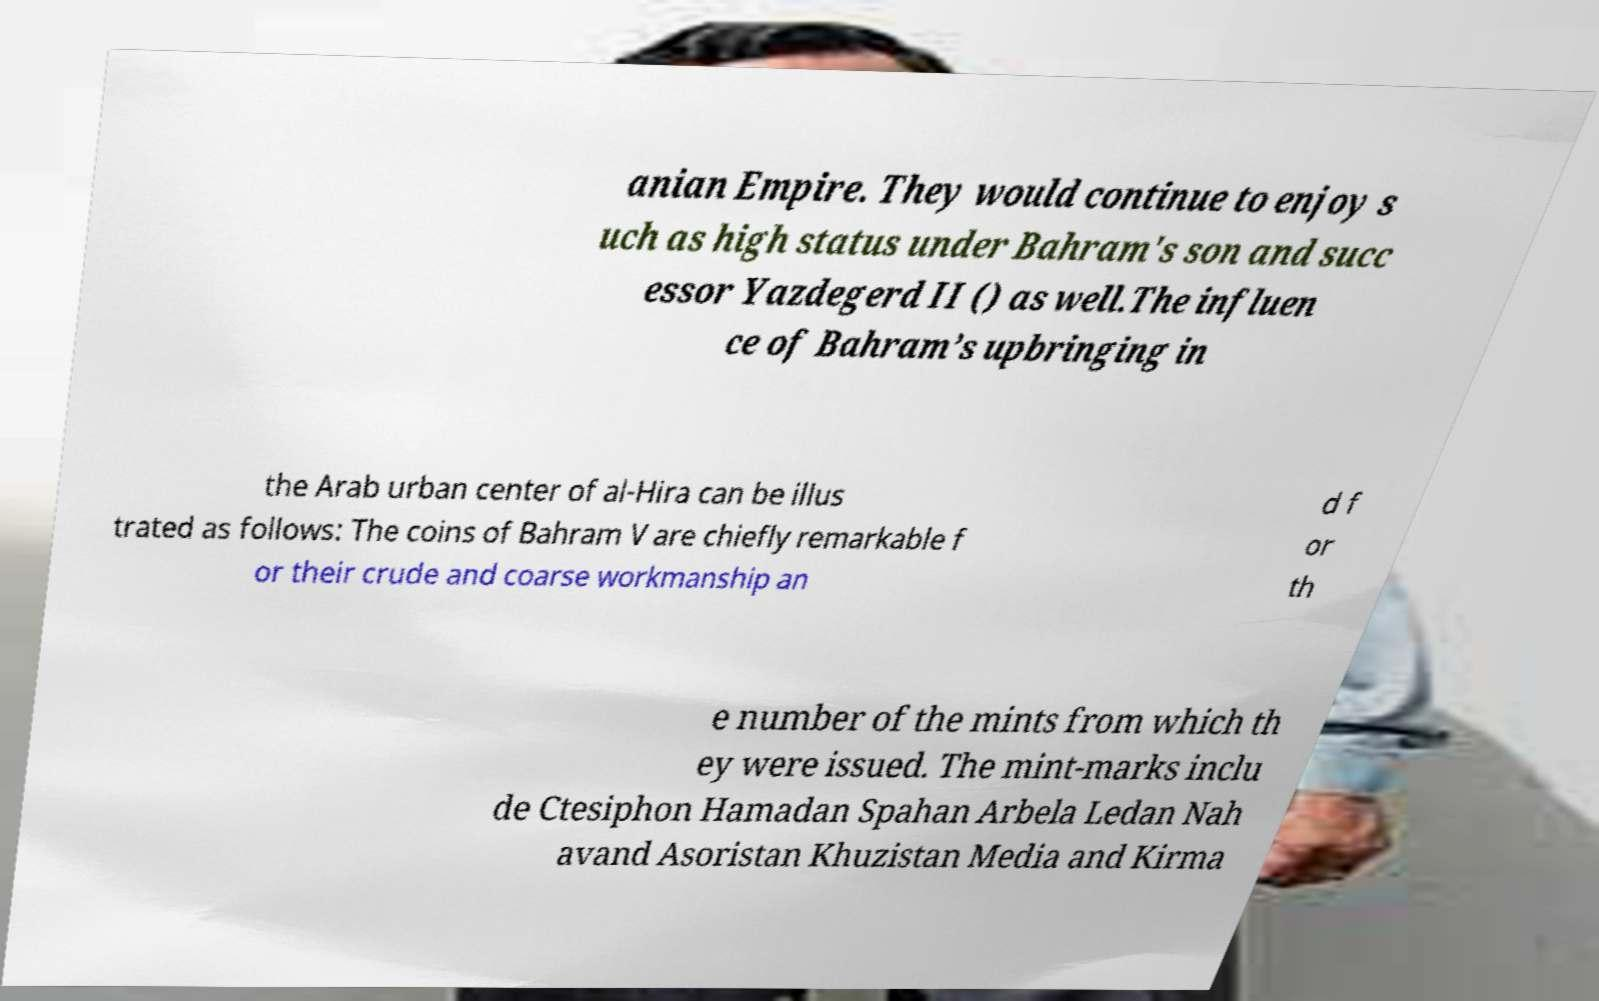Please read and relay the text visible in this image. What does it say? anian Empire. They would continue to enjoy s uch as high status under Bahram's son and succ essor Yazdegerd II () as well.The influen ce of Bahram’s upbringing in the Arab urban center of al-Hira can be illus trated as follows: The coins of Bahram V are chiefly remarkable f or their crude and coarse workmanship an d f or th e number of the mints from which th ey were issued. The mint-marks inclu de Ctesiphon Hamadan Spahan Arbela Ledan Nah avand Asoristan Khuzistan Media and Kirma 